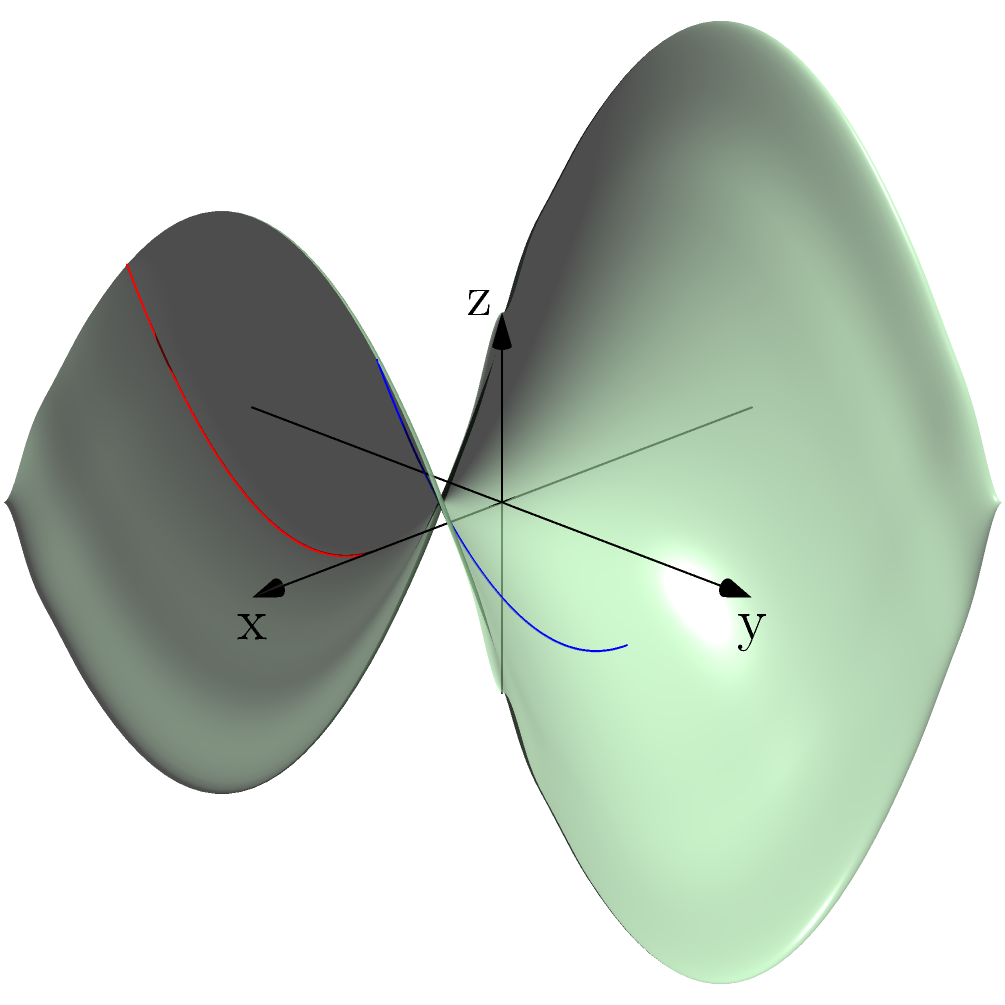On a saddle-shaped surface described by the equation $z = \frac{1}{2}(x^2 - y^2)$, two lines are drawn parallel to the x-axis at $y = 1$ and $y = -1$. As a data analyst supporting decision-making, how would you characterize the behavior of these "parallel" lines on this non-Euclidean surface? To understand the behavior of these "parallel" lines on the saddle-shaped surface, let's follow these steps:

1) First, we need to understand the surface. The equation $z = \frac{1}{2}(x^2 - y^2)$ describes a hyperbolic paraboloid, or a saddle shape.

2) The two lines are defined as follows:
   Line 1: $y = 1$, $z = \frac{1}{2}(x^2 - 1)$
   Line 2: $y = -1$, $z = \frac{1}{2}(x^2 - 1)$

3) In Euclidean geometry, parallel lines maintain a constant distance from each other. However, on this non-Euclidean surface, this property doesn't hold.

4) As x increases, both lines curve upward due to the $x^2$ term in the z-equation. However, they curve at the same rate because the equation is the same for both lines.

5) The vertical distance between the lines at any given x-coordinate is:
   $\Delta z = [\frac{1}{2}(x^2 - 1)] - [\frac{1}{2}(x^2 - 1)] = 0$

6) This means that vertically, the lines maintain a constant distance (0) from each other.

7) However, the actual distance between the points on these lines (measured along the surface) is not constant. As x increases and the surface curves more steeply, the distance along the surface between corresponding points on the two lines increases.

8) This phenomenon is a key feature of non-Euclidean geometry on curved surfaces: lines that are "parallel" in the sense of maintaining a constant coordinate difference (in this case, $\Delta y = 2$) do not maintain a constant distance when that distance is measured along the surface.
Answer: The "parallel" lines maintain constant vertical separation but diverge when distance is measured along the surface. 